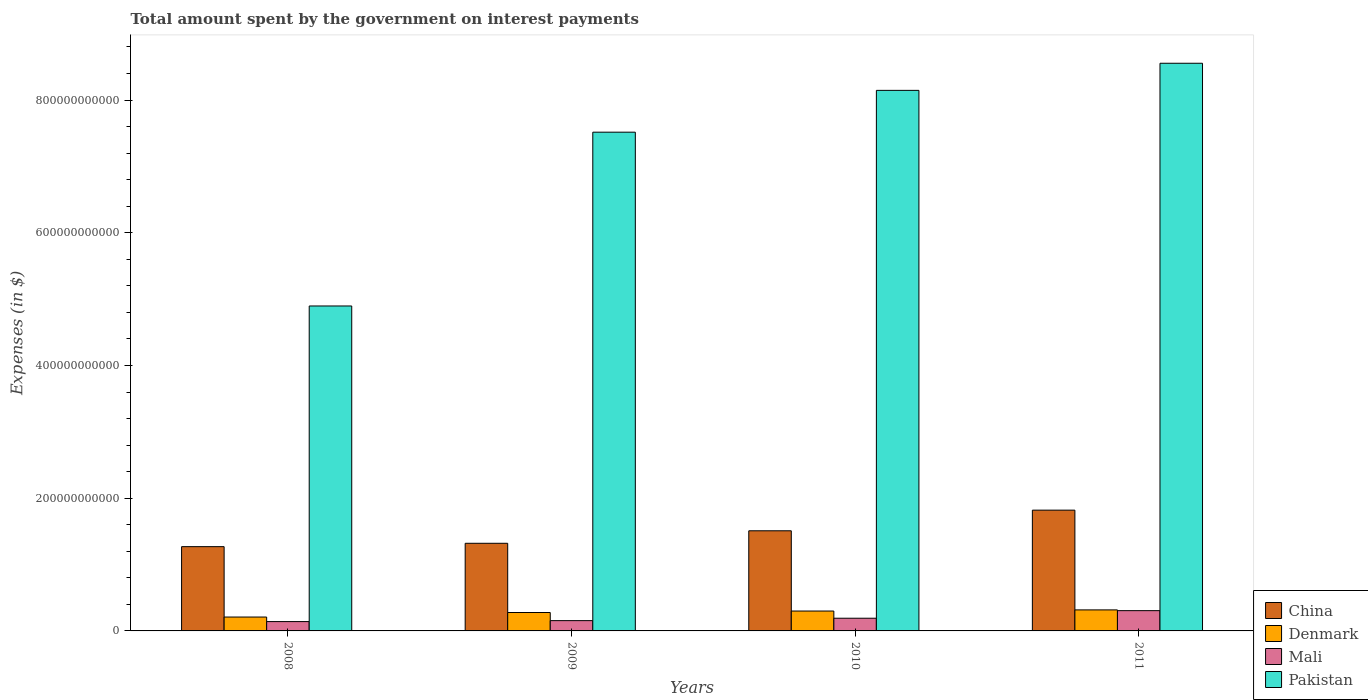How many different coloured bars are there?
Provide a short and direct response. 4. Are the number of bars per tick equal to the number of legend labels?
Provide a succinct answer. Yes. How many bars are there on the 3rd tick from the left?
Provide a short and direct response. 4. How many bars are there on the 2nd tick from the right?
Offer a very short reply. 4. What is the amount spent on interest payments by the government in China in 2008?
Offer a very short reply. 1.27e+11. Across all years, what is the maximum amount spent on interest payments by the government in Denmark?
Your response must be concise. 3.17e+1. Across all years, what is the minimum amount spent on interest payments by the government in Denmark?
Make the answer very short. 2.09e+1. What is the total amount spent on interest payments by the government in Pakistan in the graph?
Your answer should be very brief. 2.91e+12. What is the difference between the amount spent on interest payments by the government in China in 2010 and that in 2011?
Provide a succinct answer. -3.11e+1. What is the difference between the amount spent on interest payments by the government in Pakistan in 2008 and the amount spent on interest payments by the government in Denmark in 2011?
Offer a very short reply. 4.58e+11. What is the average amount spent on interest payments by the government in Mali per year?
Your answer should be compact. 1.98e+1. In the year 2008, what is the difference between the amount spent on interest payments by the government in Pakistan and amount spent on interest payments by the government in China?
Offer a very short reply. 3.63e+11. What is the ratio of the amount spent on interest payments by the government in Denmark in 2010 to that in 2011?
Give a very brief answer. 0.95. Is the amount spent on interest payments by the government in Denmark in 2008 less than that in 2010?
Your answer should be very brief. Yes. What is the difference between the highest and the second highest amount spent on interest payments by the government in Pakistan?
Make the answer very short. 4.09e+1. What is the difference between the highest and the lowest amount spent on interest payments by the government in China?
Keep it short and to the point. 5.50e+1. In how many years, is the amount spent on interest payments by the government in Denmark greater than the average amount spent on interest payments by the government in Denmark taken over all years?
Provide a short and direct response. 3. Is the sum of the amount spent on interest payments by the government in Denmark in 2008 and 2011 greater than the maximum amount spent on interest payments by the government in China across all years?
Offer a very short reply. No. Is it the case that in every year, the sum of the amount spent on interest payments by the government in Pakistan and amount spent on interest payments by the government in Denmark is greater than the sum of amount spent on interest payments by the government in Mali and amount spent on interest payments by the government in China?
Ensure brevity in your answer.  Yes. Is it the case that in every year, the sum of the amount spent on interest payments by the government in Pakistan and amount spent on interest payments by the government in Mali is greater than the amount spent on interest payments by the government in China?
Provide a short and direct response. Yes. How many bars are there?
Make the answer very short. 16. Are all the bars in the graph horizontal?
Your answer should be very brief. No. How many years are there in the graph?
Offer a very short reply. 4. What is the difference between two consecutive major ticks on the Y-axis?
Give a very brief answer. 2.00e+11. Are the values on the major ticks of Y-axis written in scientific E-notation?
Provide a succinct answer. No. Does the graph contain any zero values?
Give a very brief answer. No. Does the graph contain grids?
Offer a terse response. No. Where does the legend appear in the graph?
Keep it short and to the point. Bottom right. What is the title of the graph?
Provide a succinct answer. Total amount spent by the government on interest payments. Does "Jamaica" appear as one of the legend labels in the graph?
Provide a succinct answer. No. What is the label or title of the Y-axis?
Provide a succinct answer. Expenses (in $). What is the Expenses (in $) in China in 2008?
Give a very brief answer. 1.27e+11. What is the Expenses (in $) of Denmark in 2008?
Your response must be concise. 2.09e+1. What is the Expenses (in $) of Mali in 2008?
Give a very brief answer. 1.41e+1. What is the Expenses (in $) in Pakistan in 2008?
Your response must be concise. 4.90e+11. What is the Expenses (in $) of China in 2009?
Make the answer very short. 1.32e+11. What is the Expenses (in $) in Denmark in 2009?
Provide a succinct answer. 2.78e+1. What is the Expenses (in $) of Mali in 2009?
Offer a terse response. 1.55e+1. What is the Expenses (in $) in Pakistan in 2009?
Give a very brief answer. 7.52e+11. What is the Expenses (in $) in China in 2010?
Offer a very short reply. 1.51e+11. What is the Expenses (in $) of Denmark in 2010?
Offer a terse response. 3.00e+1. What is the Expenses (in $) of Mali in 2010?
Your response must be concise. 1.91e+1. What is the Expenses (in $) in Pakistan in 2010?
Offer a very short reply. 8.15e+11. What is the Expenses (in $) of China in 2011?
Offer a terse response. 1.82e+11. What is the Expenses (in $) of Denmark in 2011?
Offer a very short reply. 3.17e+1. What is the Expenses (in $) in Mali in 2011?
Your answer should be very brief. 3.06e+1. What is the Expenses (in $) of Pakistan in 2011?
Offer a very short reply. 8.55e+11. Across all years, what is the maximum Expenses (in $) of China?
Provide a short and direct response. 1.82e+11. Across all years, what is the maximum Expenses (in $) of Denmark?
Keep it short and to the point. 3.17e+1. Across all years, what is the maximum Expenses (in $) of Mali?
Your response must be concise. 3.06e+1. Across all years, what is the maximum Expenses (in $) of Pakistan?
Your response must be concise. 8.55e+11. Across all years, what is the minimum Expenses (in $) of China?
Your answer should be very brief. 1.27e+11. Across all years, what is the minimum Expenses (in $) in Denmark?
Make the answer very short. 2.09e+1. Across all years, what is the minimum Expenses (in $) of Mali?
Your answer should be very brief. 1.41e+1. Across all years, what is the minimum Expenses (in $) in Pakistan?
Offer a very short reply. 4.90e+11. What is the total Expenses (in $) in China in the graph?
Your answer should be compact. 5.92e+11. What is the total Expenses (in $) in Denmark in the graph?
Your response must be concise. 1.10e+11. What is the total Expenses (in $) of Mali in the graph?
Offer a terse response. 7.93e+1. What is the total Expenses (in $) of Pakistan in the graph?
Make the answer very short. 2.91e+12. What is the difference between the Expenses (in $) in China in 2008 and that in 2009?
Your answer should be compact. -5.07e+09. What is the difference between the Expenses (in $) of Denmark in 2008 and that in 2009?
Your response must be concise. -6.84e+09. What is the difference between the Expenses (in $) of Mali in 2008 and that in 2009?
Your answer should be compact. -1.42e+09. What is the difference between the Expenses (in $) in Pakistan in 2008 and that in 2009?
Provide a short and direct response. -2.62e+11. What is the difference between the Expenses (in $) of China in 2008 and that in 2010?
Offer a terse response. -2.39e+1. What is the difference between the Expenses (in $) in Denmark in 2008 and that in 2010?
Your answer should be very brief. -9.05e+09. What is the difference between the Expenses (in $) in Mali in 2008 and that in 2010?
Ensure brevity in your answer.  -5.05e+09. What is the difference between the Expenses (in $) in Pakistan in 2008 and that in 2010?
Offer a very short reply. -3.25e+11. What is the difference between the Expenses (in $) in China in 2008 and that in 2011?
Offer a very short reply. -5.50e+1. What is the difference between the Expenses (in $) of Denmark in 2008 and that in 2011?
Keep it short and to the point. -1.08e+1. What is the difference between the Expenses (in $) in Mali in 2008 and that in 2011?
Keep it short and to the point. -1.65e+1. What is the difference between the Expenses (in $) of Pakistan in 2008 and that in 2011?
Your answer should be compact. -3.66e+11. What is the difference between the Expenses (in $) of China in 2009 and that in 2010?
Ensure brevity in your answer.  -1.88e+1. What is the difference between the Expenses (in $) of Denmark in 2009 and that in 2010?
Provide a succinct answer. -2.21e+09. What is the difference between the Expenses (in $) of Mali in 2009 and that in 2010?
Ensure brevity in your answer.  -3.63e+09. What is the difference between the Expenses (in $) in Pakistan in 2009 and that in 2010?
Your answer should be very brief. -6.30e+1. What is the difference between the Expenses (in $) of China in 2009 and that in 2011?
Ensure brevity in your answer.  -4.99e+1. What is the difference between the Expenses (in $) in Denmark in 2009 and that in 2011?
Offer a very short reply. -3.92e+09. What is the difference between the Expenses (in $) of Mali in 2009 and that in 2011?
Your answer should be compact. -1.51e+1. What is the difference between the Expenses (in $) in Pakistan in 2009 and that in 2011?
Provide a short and direct response. -1.04e+11. What is the difference between the Expenses (in $) of China in 2010 and that in 2011?
Ensure brevity in your answer.  -3.11e+1. What is the difference between the Expenses (in $) in Denmark in 2010 and that in 2011?
Provide a succinct answer. -1.71e+09. What is the difference between the Expenses (in $) in Mali in 2010 and that in 2011?
Make the answer very short. -1.14e+1. What is the difference between the Expenses (in $) of Pakistan in 2010 and that in 2011?
Offer a terse response. -4.09e+1. What is the difference between the Expenses (in $) in China in 2008 and the Expenses (in $) in Denmark in 2009?
Your answer should be compact. 9.92e+1. What is the difference between the Expenses (in $) of China in 2008 and the Expenses (in $) of Mali in 2009?
Your response must be concise. 1.12e+11. What is the difference between the Expenses (in $) in China in 2008 and the Expenses (in $) in Pakistan in 2009?
Make the answer very short. -6.25e+11. What is the difference between the Expenses (in $) in Denmark in 2008 and the Expenses (in $) in Mali in 2009?
Your response must be concise. 5.42e+09. What is the difference between the Expenses (in $) of Denmark in 2008 and the Expenses (in $) of Pakistan in 2009?
Your answer should be compact. -7.31e+11. What is the difference between the Expenses (in $) of Mali in 2008 and the Expenses (in $) of Pakistan in 2009?
Keep it short and to the point. -7.38e+11. What is the difference between the Expenses (in $) in China in 2008 and the Expenses (in $) in Denmark in 2010?
Your answer should be compact. 9.70e+1. What is the difference between the Expenses (in $) in China in 2008 and the Expenses (in $) in Mali in 2010?
Give a very brief answer. 1.08e+11. What is the difference between the Expenses (in $) in China in 2008 and the Expenses (in $) in Pakistan in 2010?
Offer a terse response. -6.88e+11. What is the difference between the Expenses (in $) of Denmark in 2008 and the Expenses (in $) of Mali in 2010?
Offer a terse response. 1.79e+09. What is the difference between the Expenses (in $) in Denmark in 2008 and the Expenses (in $) in Pakistan in 2010?
Keep it short and to the point. -7.94e+11. What is the difference between the Expenses (in $) in Mali in 2008 and the Expenses (in $) in Pakistan in 2010?
Provide a succinct answer. -8.01e+11. What is the difference between the Expenses (in $) in China in 2008 and the Expenses (in $) in Denmark in 2011?
Give a very brief answer. 9.53e+1. What is the difference between the Expenses (in $) in China in 2008 and the Expenses (in $) in Mali in 2011?
Offer a terse response. 9.64e+1. What is the difference between the Expenses (in $) of China in 2008 and the Expenses (in $) of Pakistan in 2011?
Keep it short and to the point. -7.28e+11. What is the difference between the Expenses (in $) in Denmark in 2008 and the Expenses (in $) in Mali in 2011?
Offer a very short reply. -9.64e+09. What is the difference between the Expenses (in $) in Denmark in 2008 and the Expenses (in $) in Pakistan in 2011?
Ensure brevity in your answer.  -8.35e+11. What is the difference between the Expenses (in $) in Mali in 2008 and the Expenses (in $) in Pakistan in 2011?
Give a very brief answer. -8.41e+11. What is the difference between the Expenses (in $) of China in 2009 and the Expenses (in $) of Denmark in 2010?
Your answer should be very brief. 1.02e+11. What is the difference between the Expenses (in $) in China in 2009 and the Expenses (in $) in Mali in 2010?
Offer a terse response. 1.13e+11. What is the difference between the Expenses (in $) of China in 2009 and the Expenses (in $) of Pakistan in 2010?
Keep it short and to the point. -6.83e+11. What is the difference between the Expenses (in $) of Denmark in 2009 and the Expenses (in $) of Mali in 2010?
Your answer should be compact. 8.63e+09. What is the difference between the Expenses (in $) in Denmark in 2009 and the Expenses (in $) in Pakistan in 2010?
Provide a succinct answer. -7.87e+11. What is the difference between the Expenses (in $) in Mali in 2009 and the Expenses (in $) in Pakistan in 2010?
Give a very brief answer. -7.99e+11. What is the difference between the Expenses (in $) of China in 2009 and the Expenses (in $) of Denmark in 2011?
Keep it short and to the point. 1.00e+11. What is the difference between the Expenses (in $) of China in 2009 and the Expenses (in $) of Mali in 2011?
Offer a terse response. 1.02e+11. What is the difference between the Expenses (in $) of China in 2009 and the Expenses (in $) of Pakistan in 2011?
Your answer should be very brief. -7.23e+11. What is the difference between the Expenses (in $) in Denmark in 2009 and the Expenses (in $) in Mali in 2011?
Make the answer very short. -2.81e+09. What is the difference between the Expenses (in $) in Denmark in 2009 and the Expenses (in $) in Pakistan in 2011?
Provide a succinct answer. -8.28e+11. What is the difference between the Expenses (in $) of Mali in 2009 and the Expenses (in $) of Pakistan in 2011?
Offer a very short reply. -8.40e+11. What is the difference between the Expenses (in $) of China in 2010 and the Expenses (in $) of Denmark in 2011?
Your response must be concise. 1.19e+11. What is the difference between the Expenses (in $) in China in 2010 and the Expenses (in $) in Mali in 2011?
Ensure brevity in your answer.  1.20e+11. What is the difference between the Expenses (in $) in China in 2010 and the Expenses (in $) in Pakistan in 2011?
Keep it short and to the point. -7.05e+11. What is the difference between the Expenses (in $) in Denmark in 2010 and the Expenses (in $) in Mali in 2011?
Provide a short and direct response. -5.98e+08. What is the difference between the Expenses (in $) of Denmark in 2010 and the Expenses (in $) of Pakistan in 2011?
Offer a very short reply. -8.26e+11. What is the difference between the Expenses (in $) in Mali in 2010 and the Expenses (in $) in Pakistan in 2011?
Provide a succinct answer. -8.36e+11. What is the average Expenses (in $) of China per year?
Offer a terse response. 1.48e+11. What is the average Expenses (in $) of Denmark per year?
Make the answer very short. 2.76e+1. What is the average Expenses (in $) in Mali per year?
Provide a short and direct response. 1.98e+1. What is the average Expenses (in $) in Pakistan per year?
Provide a short and direct response. 7.28e+11. In the year 2008, what is the difference between the Expenses (in $) of China and Expenses (in $) of Denmark?
Your response must be concise. 1.06e+11. In the year 2008, what is the difference between the Expenses (in $) of China and Expenses (in $) of Mali?
Ensure brevity in your answer.  1.13e+11. In the year 2008, what is the difference between the Expenses (in $) in China and Expenses (in $) in Pakistan?
Offer a terse response. -3.63e+11. In the year 2008, what is the difference between the Expenses (in $) of Denmark and Expenses (in $) of Mali?
Your answer should be compact. 6.84e+09. In the year 2008, what is the difference between the Expenses (in $) in Denmark and Expenses (in $) in Pakistan?
Make the answer very short. -4.69e+11. In the year 2008, what is the difference between the Expenses (in $) of Mali and Expenses (in $) of Pakistan?
Offer a terse response. -4.76e+11. In the year 2009, what is the difference between the Expenses (in $) of China and Expenses (in $) of Denmark?
Ensure brevity in your answer.  1.04e+11. In the year 2009, what is the difference between the Expenses (in $) of China and Expenses (in $) of Mali?
Offer a very short reply. 1.17e+11. In the year 2009, what is the difference between the Expenses (in $) in China and Expenses (in $) in Pakistan?
Your answer should be compact. -6.20e+11. In the year 2009, what is the difference between the Expenses (in $) in Denmark and Expenses (in $) in Mali?
Provide a succinct answer. 1.23e+1. In the year 2009, what is the difference between the Expenses (in $) of Denmark and Expenses (in $) of Pakistan?
Offer a very short reply. -7.24e+11. In the year 2009, what is the difference between the Expenses (in $) of Mali and Expenses (in $) of Pakistan?
Offer a very short reply. -7.36e+11. In the year 2010, what is the difference between the Expenses (in $) in China and Expenses (in $) in Denmark?
Offer a terse response. 1.21e+11. In the year 2010, what is the difference between the Expenses (in $) of China and Expenses (in $) of Mali?
Offer a very short reply. 1.32e+11. In the year 2010, what is the difference between the Expenses (in $) in China and Expenses (in $) in Pakistan?
Provide a succinct answer. -6.64e+11. In the year 2010, what is the difference between the Expenses (in $) of Denmark and Expenses (in $) of Mali?
Keep it short and to the point. 1.08e+1. In the year 2010, what is the difference between the Expenses (in $) of Denmark and Expenses (in $) of Pakistan?
Provide a short and direct response. -7.85e+11. In the year 2010, what is the difference between the Expenses (in $) in Mali and Expenses (in $) in Pakistan?
Offer a terse response. -7.95e+11. In the year 2011, what is the difference between the Expenses (in $) in China and Expenses (in $) in Denmark?
Give a very brief answer. 1.50e+11. In the year 2011, what is the difference between the Expenses (in $) of China and Expenses (in $) of Mali?
Keep it short and to the point. 1.51e+11. In the year 2011, what is the difference between the Expenses (in $) in China and Expenses (in $) in Pakistan?
Your response must be concise. -6.73e+11. In the year 2011, what is the difference between the Expenses (in $) of Denmark and Expenses (in $) of Mali?
Your answer should be very brief. 1.12e+09. In the year 2011, what is the difference between the Expenses (in $) in Denmark and Expenses (in $) in Pakistan?
Give a very brief answer. -8.24e+11. In the year 2011, what is the difference between the Expenses (in $) in Mali and Expenses (in $) in Pakistan?
Give a very brief answer. -8.25e+11. What is the ratio of the Expenses (in $) in China in 2008 to that in 2009?
Offer a very short reply. 0.96. What is the ratio of the Expenses (in $) in Denmark in 2008 to that in 2009?
Give a very brief answer. 0.75. What is the ratio of the Expenses (in $) of Mali in 2008 to that in 2009?
Offer a very short reply. 0.91. What is the ratio of the Expenses (in $) in Pakistan in 2008 to that in 2009?
Offer a terse response. 0.65. What is the ratio of the Expenses (in $) of China in 2008 to that in 2010?
Offer a very short reply. 0.84. What is the ratio of the Expenses (in $) in Denmark in 2008 to that in 2010?
Give a very brief answer. 0.7. What is the ratio of the Expenses (in $) in Mali in 2008 to that in 2010?
Offer a terse response. 0.74. What is the ratio of the Expenses (in $) of Pakistan in 2008 to that in 2010?
Give a very brief answer. 0.6. What is the ratio of the Expenses (in $) in China in 2008 to that in 2011?
Your answer should be compact. 0.7. What is the ratio of the Expenses (in $) of Denmark in 2008 to that in 2011?
Give a very brief answer. 0.66. What is the ratio of the Expenses (in $) of Mali in 2008 to that in 2011?
Make the answer very short. 0.46. What is the ratio of the Expenses (in $) of Pakistan in 2008 to that in 2011?
Offer a terse response. 0.57. What is the ratio of the Expenses (in $) of China in 2009 to that in 2010?
Give a very brief answer. 0.88. What is the ratio of the Expenses (in $) in Denmark in 2009 to that in 2010?
Offer a very short reply. 0.93. What is the ratio of the Expenses (in $) of Mali in 2009 to that in 2010?
Make the answer very short. 0.81. What is the ratio of the Expenses (in $) of Pakistan in 2009 to that in 2010?
Offer a very short reply. 0.92. What is the ratio of the Expenses (in $) of China in 2009 to that in 2011?
Your answer should be compact. 0.73. What is the ratio of the Expenses (in $) of Denmark in 2009 to that in 2011?
Keep it short and to the point. 0.88. What is the ratio of the Expenses (in $) of Mali in 2009 to that in 2011?
Your answer should be compact. 0.51. What is the ratio of the Expenses (in $) in Pakistan in 2009 to that in 2011?
Your response must be concise. 0.88. What is the ratio of the Expenses (in $) of China in 2010 to that in 2011?
Provide a succinct answer. 0.83. What is the ratio of the Expenses (in $) of Denmark in 2010 to that in 2011?
Offer a terse response. 0.95. What is the ratio of the Expenses (in $) of Mali in 2010 to that in 2011?
Your answer should be compact. 0.63. What is the ratio of the Expenses (in $) of Pakistan in 2010 to that in 2011?
Provide a short and direct response. 0.95. What is the difference between the highest and the second highest Expenses (in $) in China?
Give a very brief answer. 3.11e+1. What is the difference between the highest and the second highest Expenses (in $) in Denmark?
Your answer should be very brief. 1.71e+09. What is the difference between the highest and the second highest Expenses (in $) in Mali?
Offer a very short reply. 1.14e+1. What is the difference between the highest and the second highest Expenses (in $) of Pakistan?
Provide a succinct answer. 4.09e+1. What is the difference between the highest and the lowest Expenses (in $) in China?
Offer a terse response. 5.50e+1. What is the difference between the highest and the lowest Expenses (in $) in Denmark?
Make the answer very short. 1.08e+1. What is the difference between the highest and the lowest Expenses (in $) in Mali?
Give a very brief answer. 1.65e+1. What is the difference between the highest and the lowest Expenses (in $) of Pakistan?
Keep it short and to the point. 3.66e+11. 